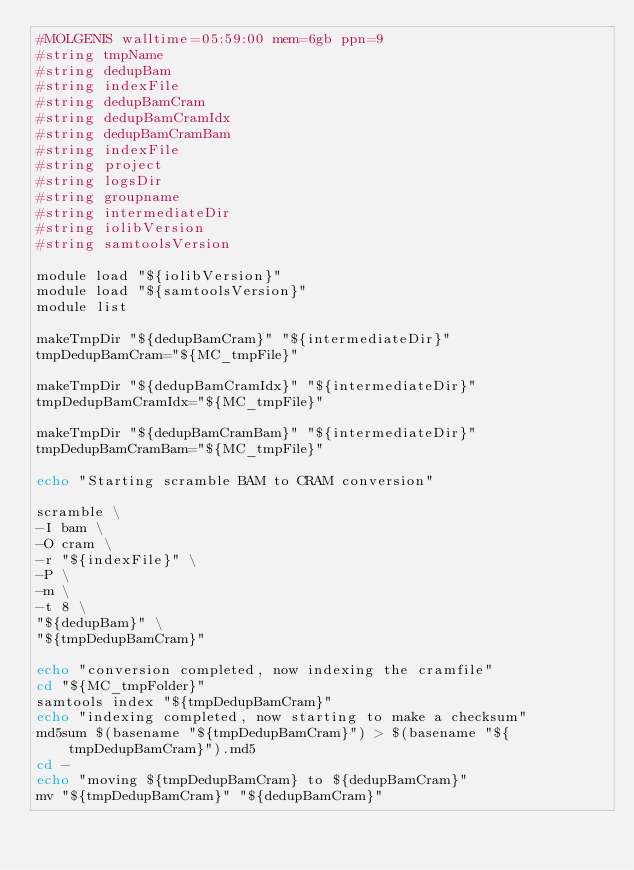<code> <loc_0><loc_0><loc_500><loc_500><_Bash_>#MOLGENIS walltime=05:59:00 mem=6gb ppn=9
#string tmpName
#string dedupBam
#string indexFile
#string dedupBamCram
#string dedupBamCramIdx
#string dedupBamCramBam
#string indexFile
#string	project
#string logsDir
#string groupname
#string intermediateDir
#string iolibVersion
#string samtoolsVersion

module load "${iolibVersion}"
module load "${samtoolsVersion}"
module list

makeTmpDir "${dedupBamCram}" "${intermediateDir}"
tmpDedupBamCram="${MC_tmpFile}"

makeTmpDir "${dedupBamCramIdx}" "${intermediateDir}"
tmpDedupBamCramIdx="${MC_tmpFile}"

makeTmpDir "${dedupBamCramBam}" "${intermediateDir}"
tmpDedupBamCramBam="${MC_tmpFile}"

echo "Starting scramble BAM to CRAM conversion"

scramble \
-I bam \
-O cram \
-r "${indexFile}" \
-P \
-m \
-t 8 \
"${dedupBam}" \
"${tmpDedupBamCram}"

echo "conversion completed, now indexing the cramfile"
cd "${MC_tmpFolder}"
samtools index "${tmpDedupBamCram}"
echo "indexing completed, now starting to make a checksum"
md5sum $(basename "${tmpDedupBamCram}") > $(basename "${tmpDedupBamCram}").md5
cd -
echo "moving ${tmpDedupBamCram} to ${dedupBamCram}"
mv "${tmpDedupBamCram}" "${dedupBamCram}"
</code> 